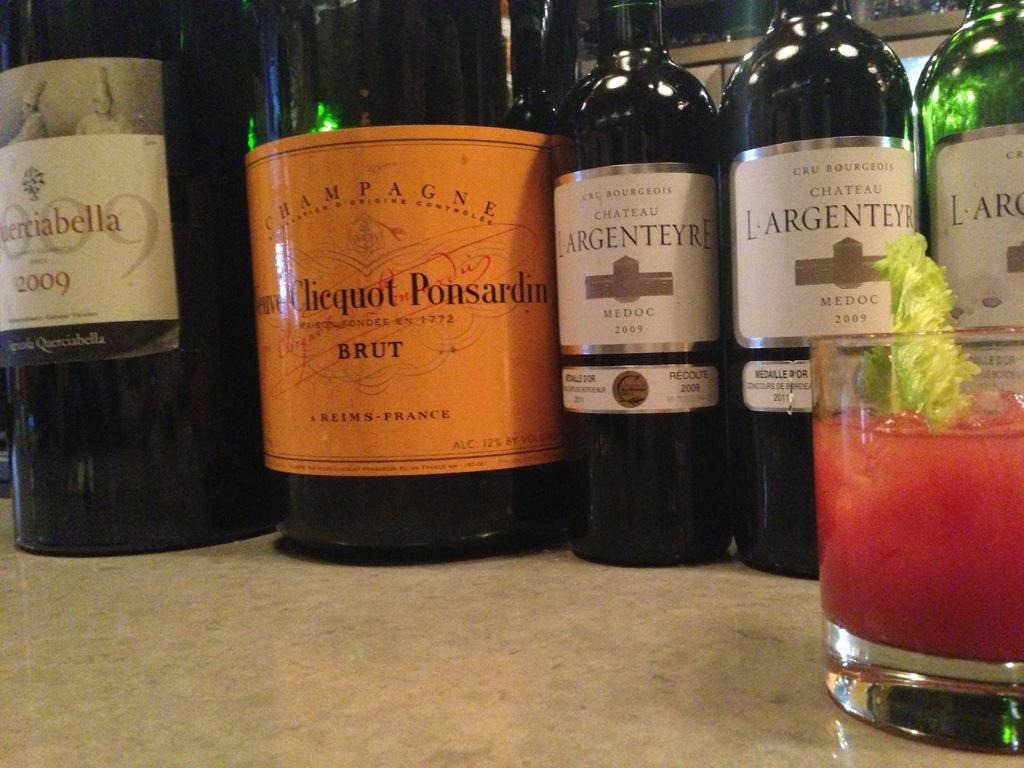<image>
Write a terse but informative summary of the picture. LARGENTEYRE wine bottles on top of a table. 